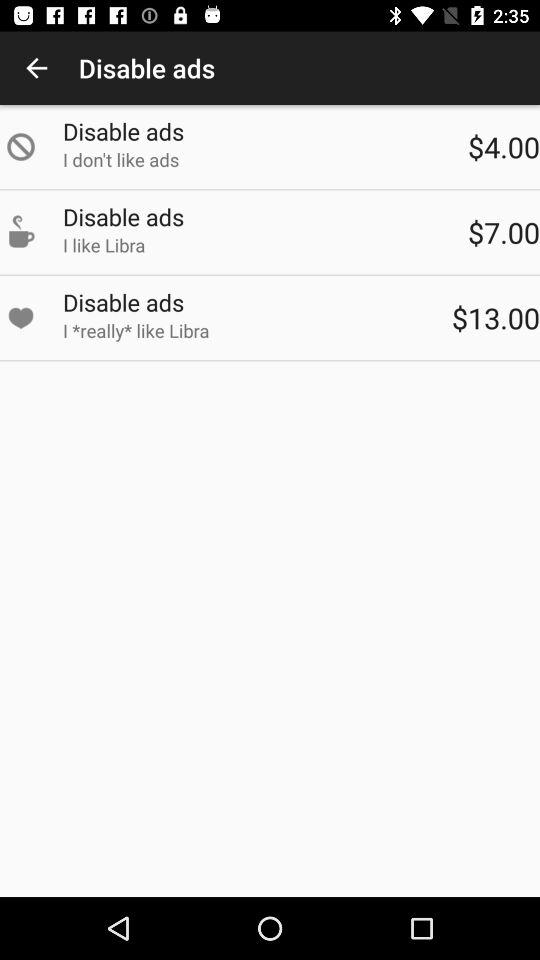How many of the options are more expensive than $5.00?
Answer the question using a single word or phrase. 2 